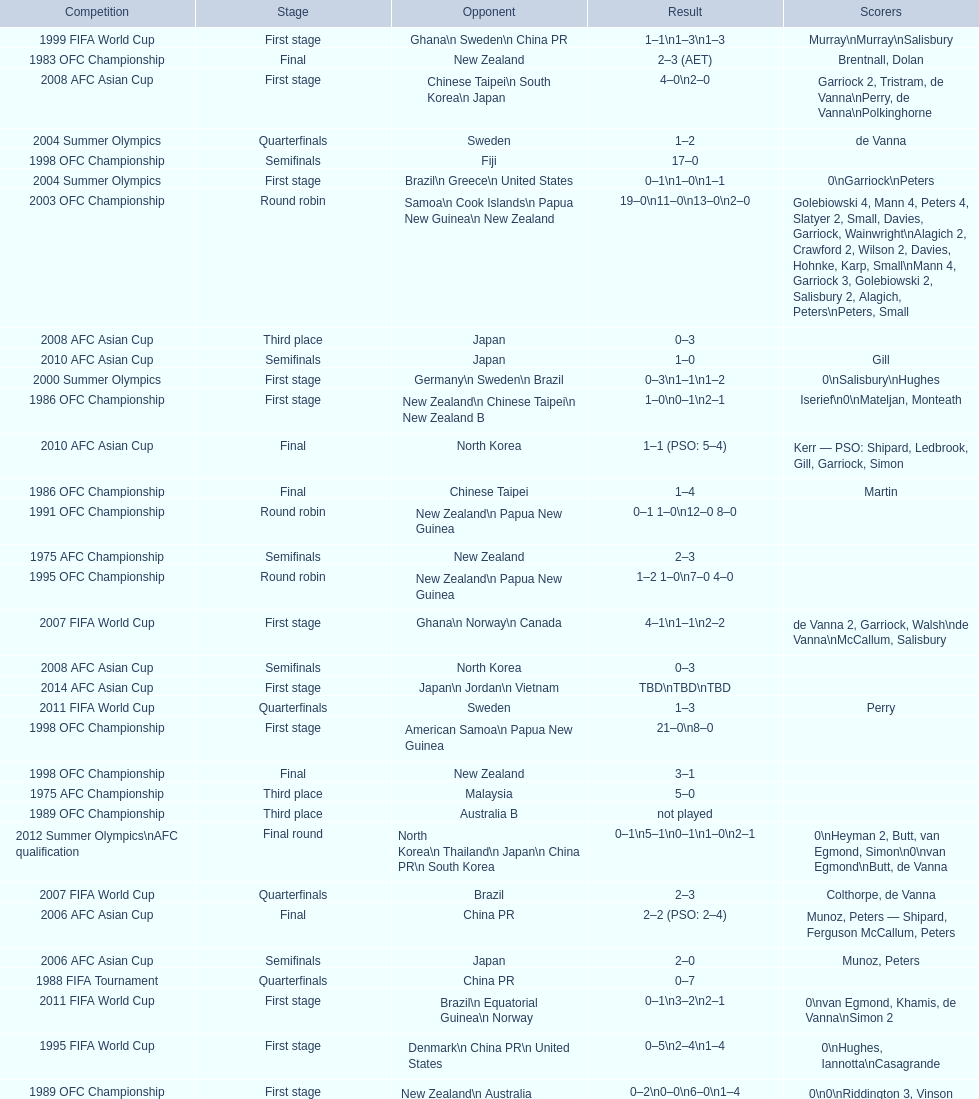What is the difference in the number of goals scored in the 1999 fifa world cup and the 2000 summer olympics? 2. 